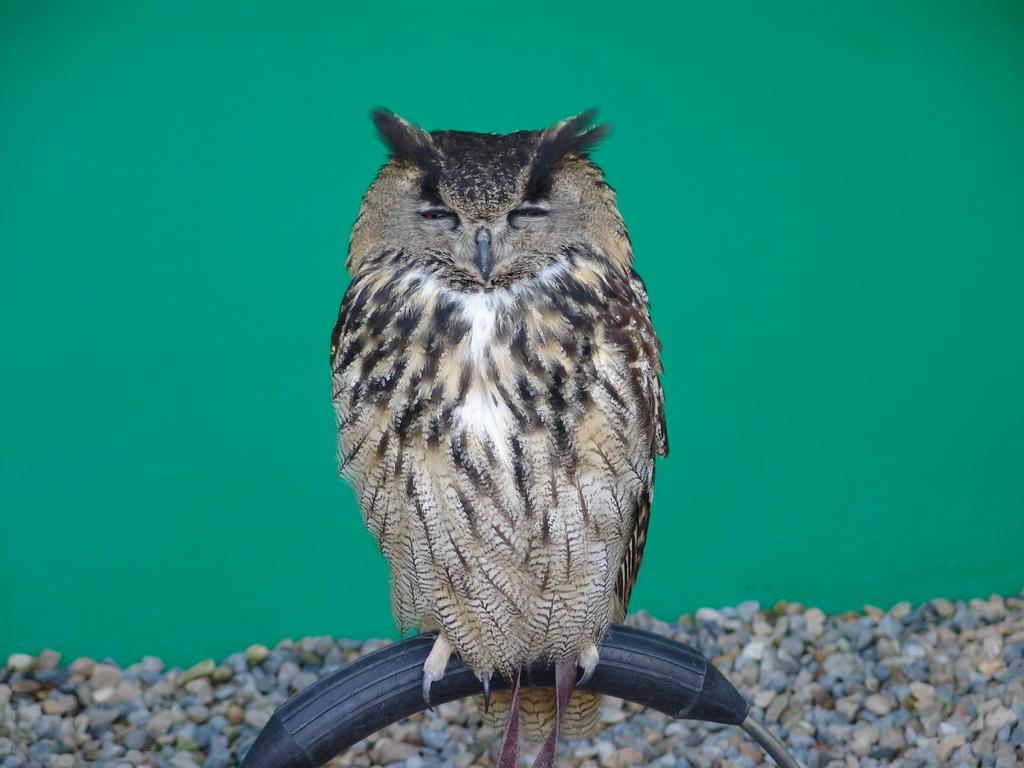What type of animal is in the image? There is an owl in the image. What is the owl resting on in the image? The owl is on an object. What type of natural elements can be seen in the background of the image? There are small stones in the background of the image. What color is the wall visible in the background of the image? There is a green-colored wall in the background of the image. What type of plantation can be seen in the image? There is no plantation present in the image. What part of the owl's body is visible in the image? The image does not show any specific part of the owl's body; it only shows the owl as a whole. 